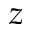Convert formula to latex. <formula><loc_0><loc_0><loc_500><loc_500>z</formula> 